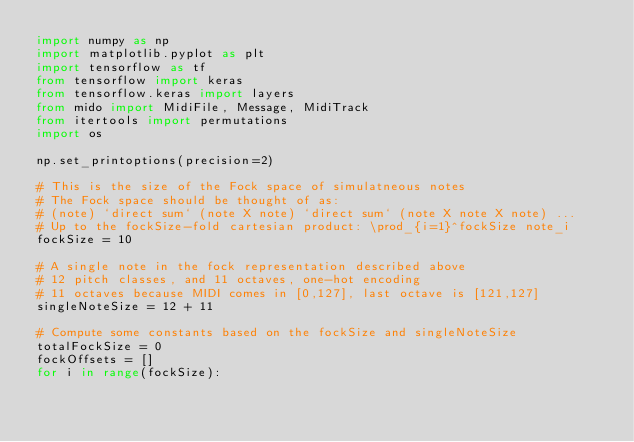Convert code to text. <code><loc_0><loc_0><loc_500><loc_500><_Python_>import numpy as np
import matplotlib.pyplot as plt
import tensorflow as tf
from tensorflow import keras
from tensorflow.keras import layers
from mido import MidiFile, Message, MidiTrack
from itertools import permutations
import os

np.set_printoptions(precision=2)

# This is the size of the Fock space of simulatneous notes
# The Fock space should be thought of as:
# (note) `direct sum` (note X note) `direct sum` (note X note X note) ...
# Up to the fockSize-fold cartesian product: \prod_{i=1}^fockSize note_i
fockSize = 10

# A single note in the fock representation described above
# 12 pitch classes, and 11 octaves, one-hot encoding
# 11 octaves because MIDI comes in [0,127], last octave is [121,127]
singleNoteSize = 12 + 11

# Compute some constants based on the fockSize and singleNoteSize
totalFockSize = 0
fockOffsets = []
for i in range(fockSize):</code> 